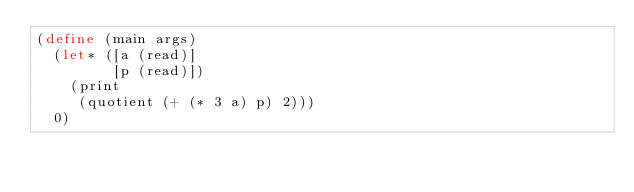Convert code to text. <code><loc_0><loc_0><loc_500><loc_500><_Scheme_>(define (main args)
  (let* ([a (read)]
         [p (read)])
    (print
     (quotient (+ (* 3 a) p) 2)))
  0)
</code> 